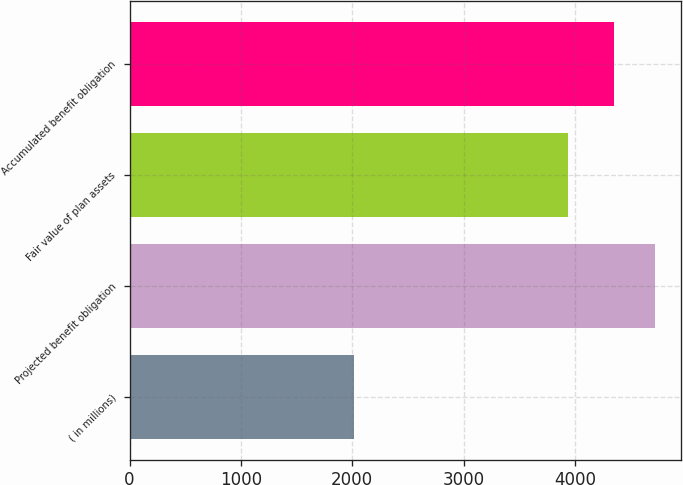<chart> <loc_0><loc_0><loc_500><loc_500><bar_chart><fcel>( in millions)<fcel>Projected benefit obligation<fcel>Fair value of plan assets<fcel>Accumulated benefit obligation<nl><fcel>2015<fcel>4717<fcel>3937<fcel>4351<nl></chart> 